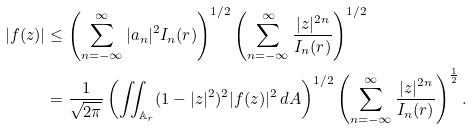Convert formula to latex. <formula><loc_0><loc_0><loc_500><loc_500>| f ( z ) | & \leq \left ( \sum _ { n = - \infty } ^ { \infty } | a _ { n } | ^ { 2 } I _ { n } ( r ) \right ) ^ { 1 / 2 } \left ( \sum _ { n = - \infty } ^ { \infty } \frac { | z | ^ { 2 n } } { I _ { n } ( r ) } \right ) ^ { 1 / 2 } \\ & = \frac { 1 } { \sqrt { 2 \pi } } \left ( \iint _ { \mathbb { A } _ { r } } ( 1 - | z | ^ { 2 } ) ^ { 2 } | f ( z ) | ^ { 2 } \, d A \right ) ^ { 1 / 2 } \left ( \sum _ { n = - \infty } ^ { \infty } \frac { | z | ^ { 2 n } } { I _ { n } ( r ) } \right ) ^ { \frac { 1 } { 2 } } .</formula> 